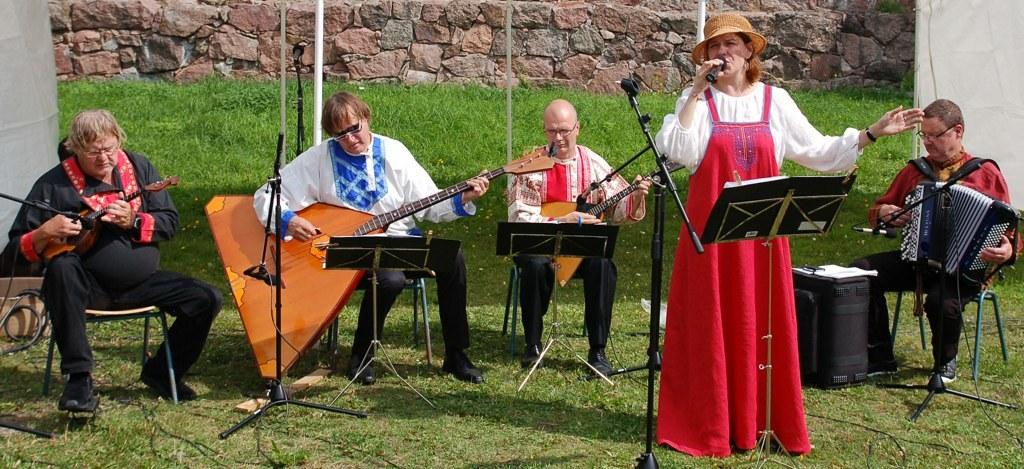What is the person in the image wearing? The person is wearing a red dress in the image. What is the person doing in the image? The person is singing in the image. What is the person using to amplify their voice? There is a microphone in front of the person. What else can be seen in the image? There is a group of people playing music in the image. What degree does the person's mother have in the image? There is no mention of the person's mother or any degrees in the image. 